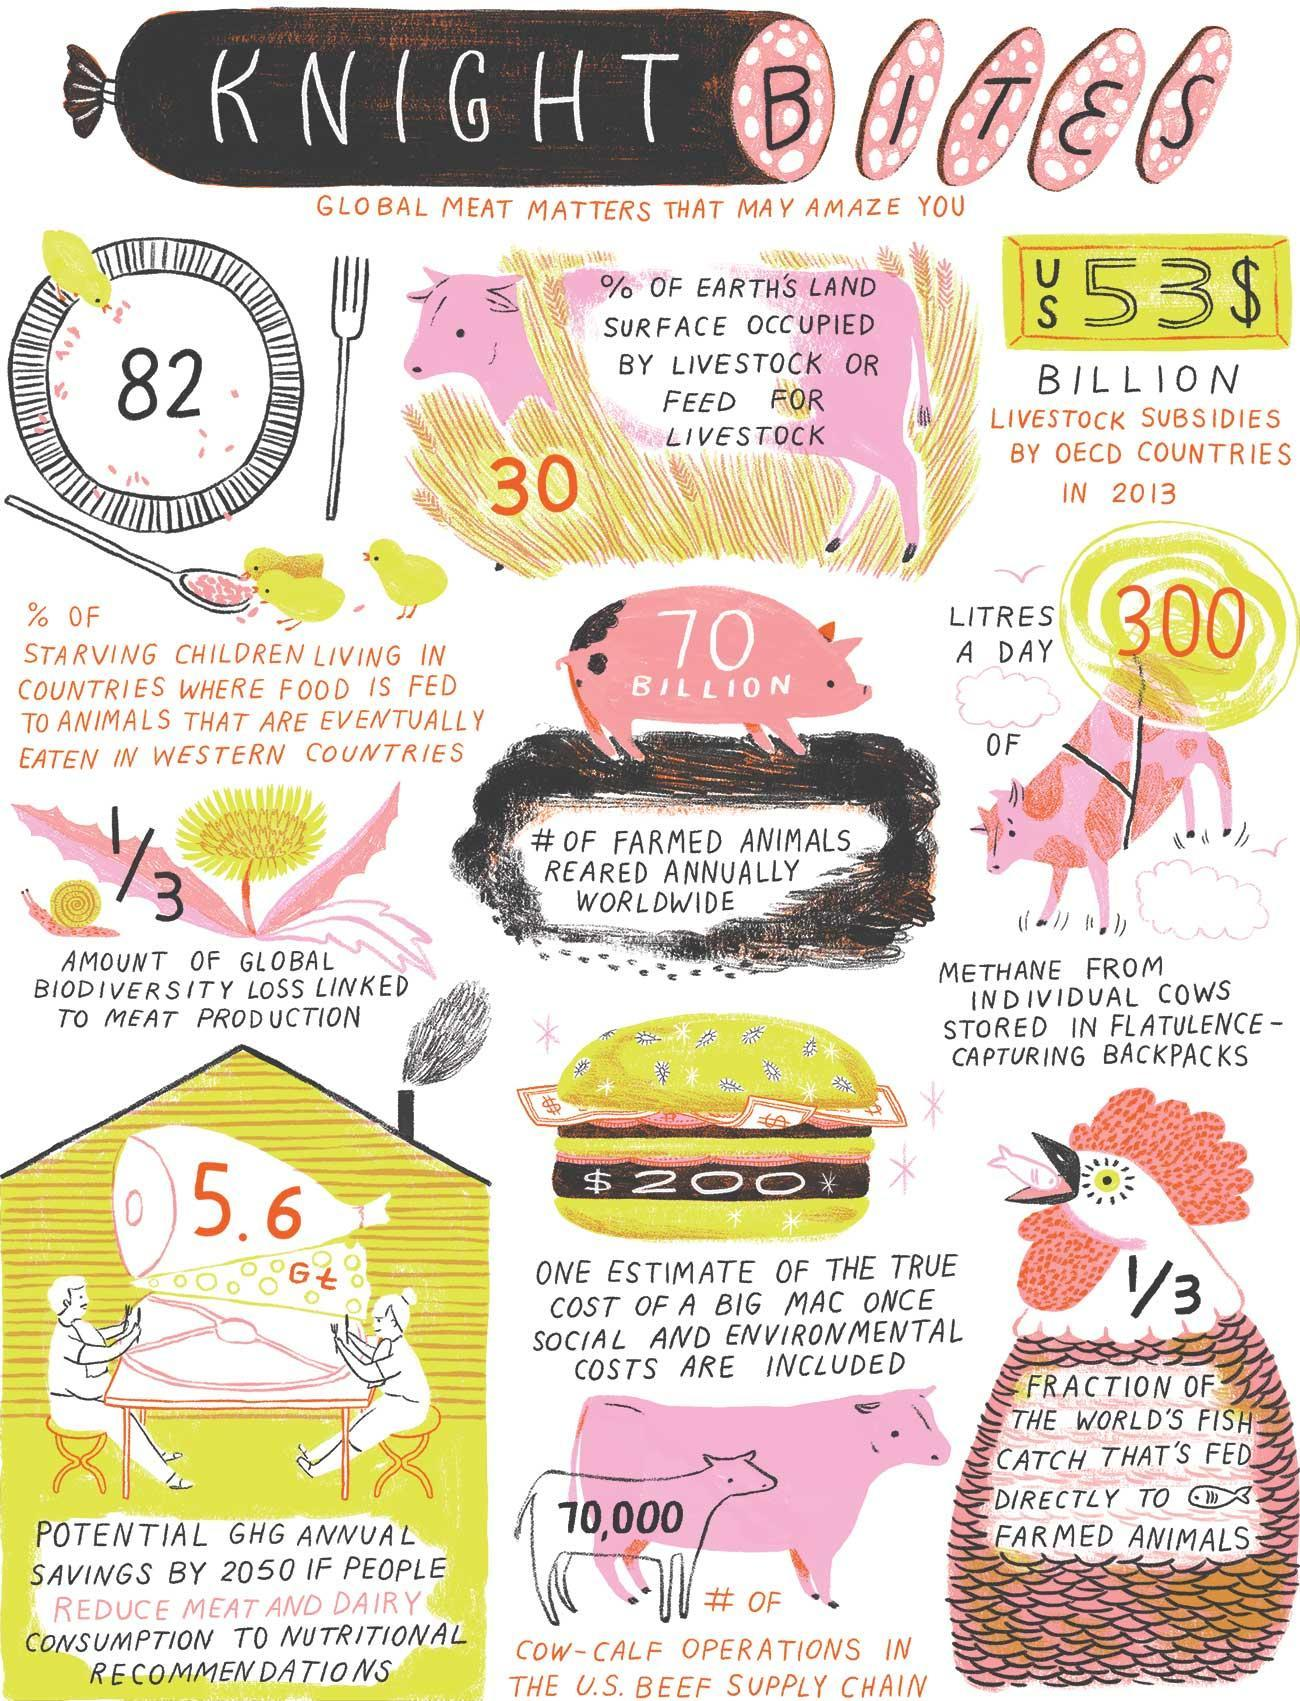How many litres of methane from individual cows are stored in flatulence-capturing backpacks in a day?
Answer the question with a short phrase. 300 What is the potential GHG annual savings by 2050 if people reduce meat & diary consumption to nutritional recommendations? 5.6 Gt What percentage of starving children are living in countries where food is fed to animals that are eventually eaten in western countries? 82 What is the number of cow-calf operations in the U.S. beef supply chain? 70,000 What is the number of farmed animals reared annually worldwide? 70 BILLION What percentage of earth's land surface are occupied by livestock or feed for livestock? 30 